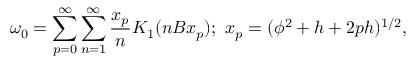Convert formula to latex. <formula><loc_0><loc_0><loc_500><loc_500>\omega _ { 0 } = \sum _ { p = 0 } ^ { \infty } \sum _ { n = 1 } ^ { \infty } \frac { x _ { p } } { n } K _ { 1 } ( n B x _ { p } ) ; x _ { p } = ( \phi ^ { 2 } + h + 2 p h ) ^ { 1 / 2 } ,</formula> 